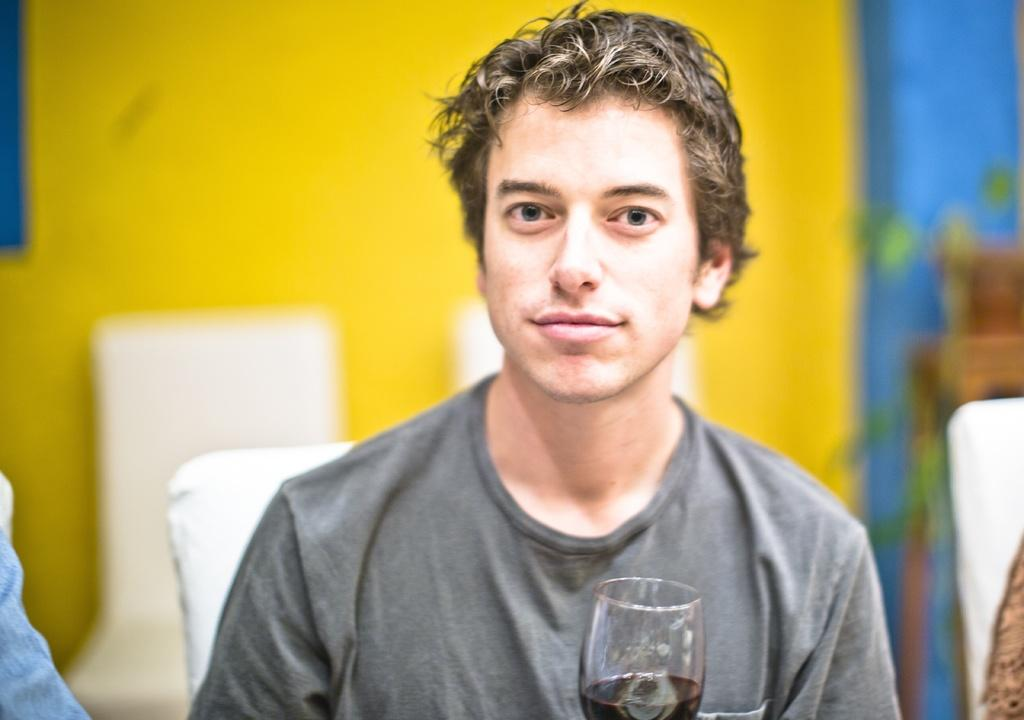What is the main subject of the image? The main subject of the image is a man. What is the man holding in the image? The man is holding a glass with a drink. Can you describe the background of the image? The background of the man is blurry. What is the man wearing in the image? The man is wearing a grey t-shirt. What type of bone can be seen in the man's hand in the image? There is no bone visible in the man's hand in the image; he is holding a glass with a drink. What achievement is the man celebrating in the image? There is no indication of an achievement being celebrated in the image. 